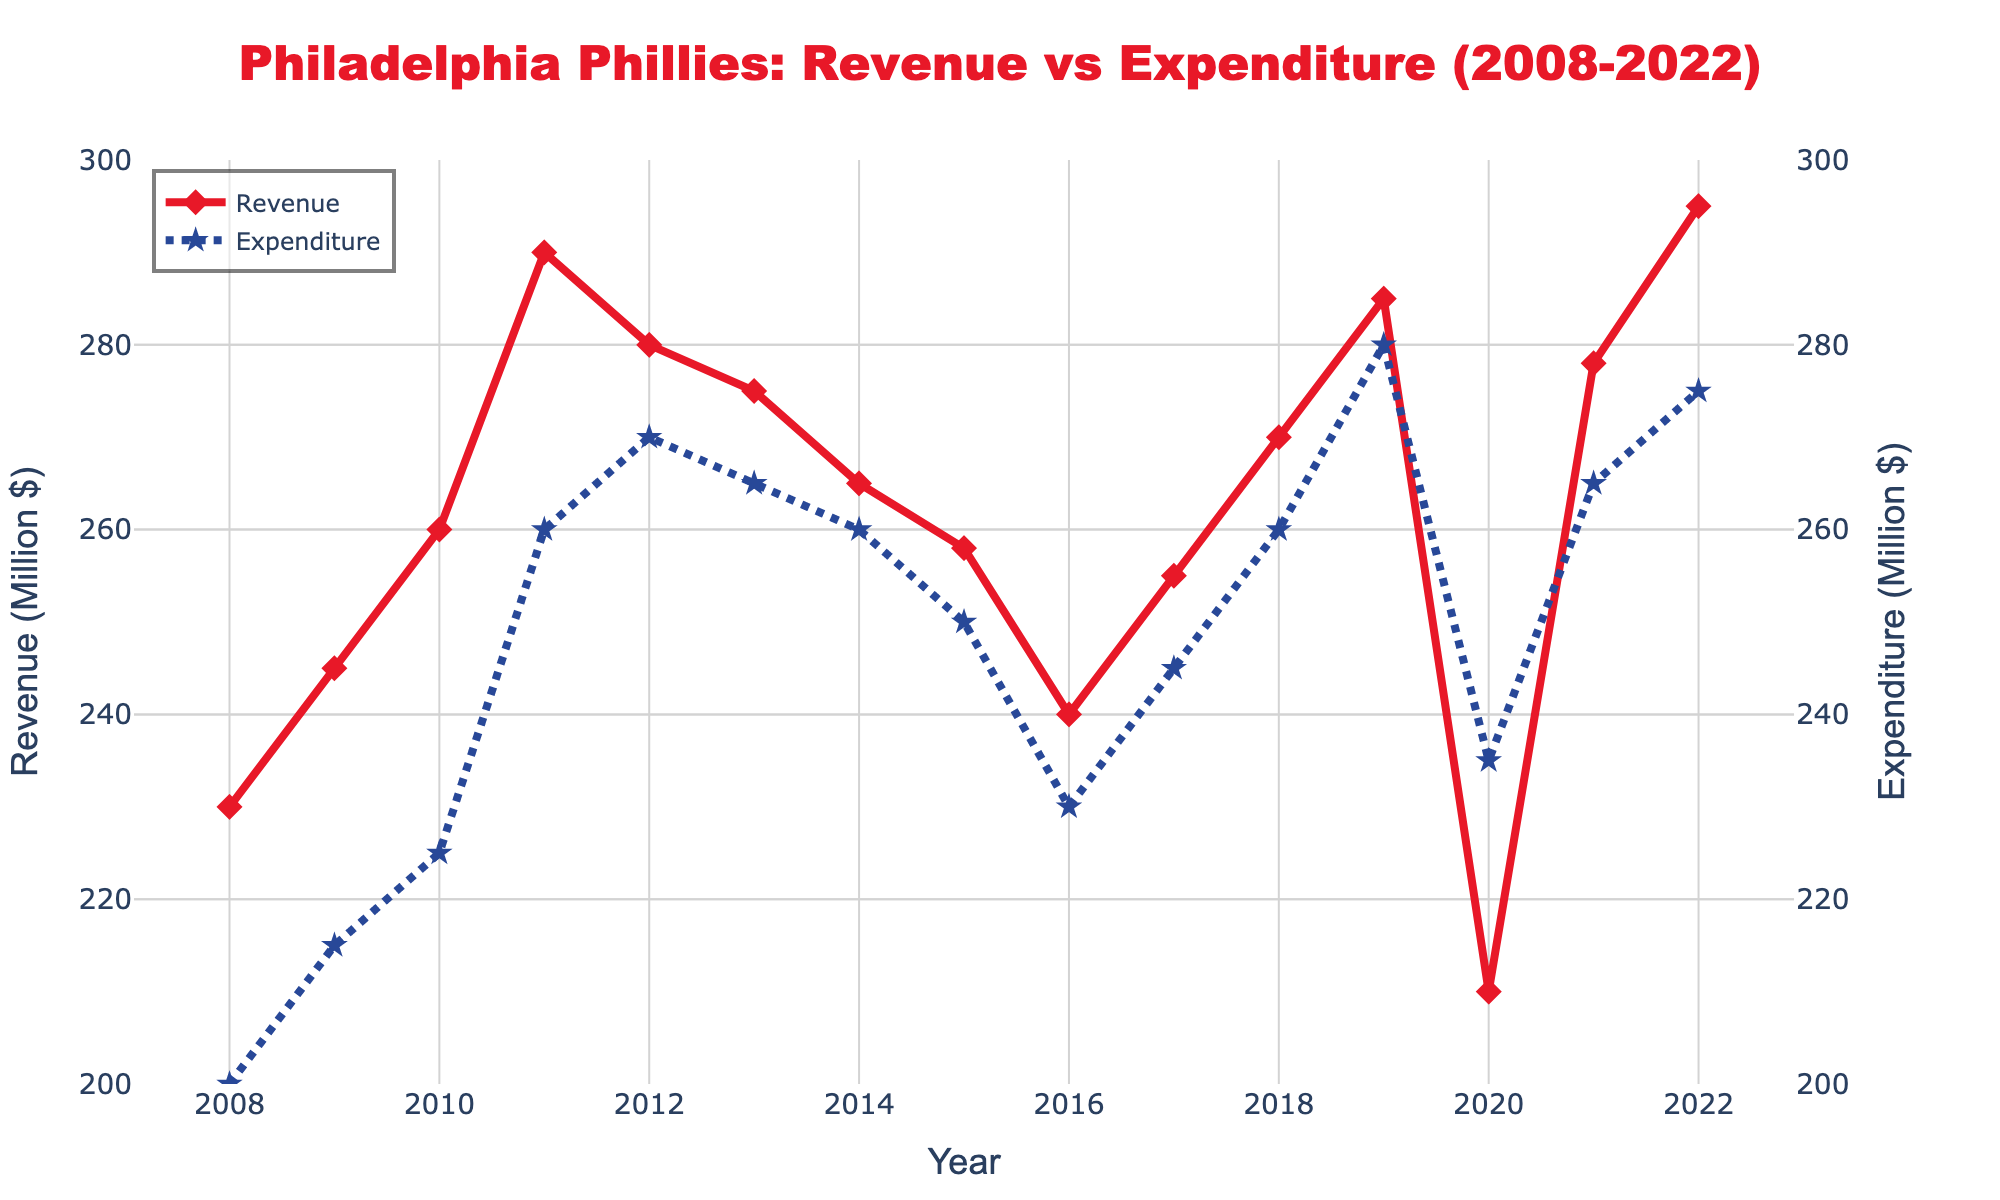What is the title of the figure? The title of the figure is displayed prominently at the top in large font. It reads, "Philadelphia Phillies: Revenue vs Expenditure (2008-2022)"
Answer: Philadelphia Phillies: Revenue vs Expenditure (2008-2022) How many years of data are displayed in the figure? The x-axis shows data points from 2008 to 2022, inclusive. Count these years to find the number of data points.
Answer: 15 Which year had the highest expenditure amount? Look at the dashed line with star markers representing Expenditure and identify the highest point along this line. This point corresponds to the year 2019.
Answer: 2019 What were the revenue and expenditure amounts in 2020? Find the year 2020 along the x-axis and read the corresponding values for both the Revenue line (solid with diamond markers) and the Expenditure line (dashed with star markers).
Answer: Revenue: $210 million, Expenditure: $235 million How does the revenue in 2018 compare to the revenue in 2008? Locate 2008 and 2018 on the x-axis and compare the heights of the corresponding points on the Revenue line. Revenue in 2018 was $270 million, whereas in 2008 it was $230 million.
Answer: 2018 revenue is higher What is the average expenditure from 2008 to 2022? Sum the expenditure values from each year and divide by the number of years. \( \frac{200 + 215 + 225 + 260 + 270 + 265 + 260 + 250 + 230 + 245 + 260 + 280 + 235 + 265 + 275}{15} \approx 251.33 \)
Answer: $251.33 million Between which two adjacent years did the expenditure increase the most? Look at the year-to-year changes in the Expenditure line. The largest increase is from 2018 ($260 million) to 2019 ($280 million), a change of $20 million.
Answer: Between 2018 and 2019 What is the overall trend of the revenue from 2008 to 2022? Observe the general direction of the Revenue line from 2008 to 2022. The trend shows an overall increase, with some fluctuations.
Answer: Overall increasing trend What was the revenue in 2011, and how much was the net gain/loss compared to the expenditure that year? Identify the Revenue and Expenditure values for 2011 (Revenue: $290 million, Expenditure: $260 million). Calculate the difference, \( 290 - 260 = 30 \).
Answer: Revenue: $290 million, Net gain: $30 million 